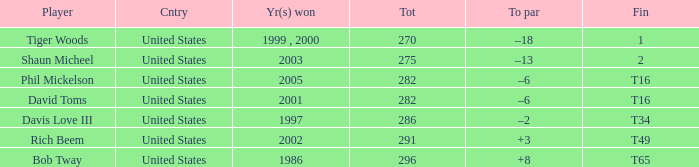What is Davis Love III's total? 286.0. 